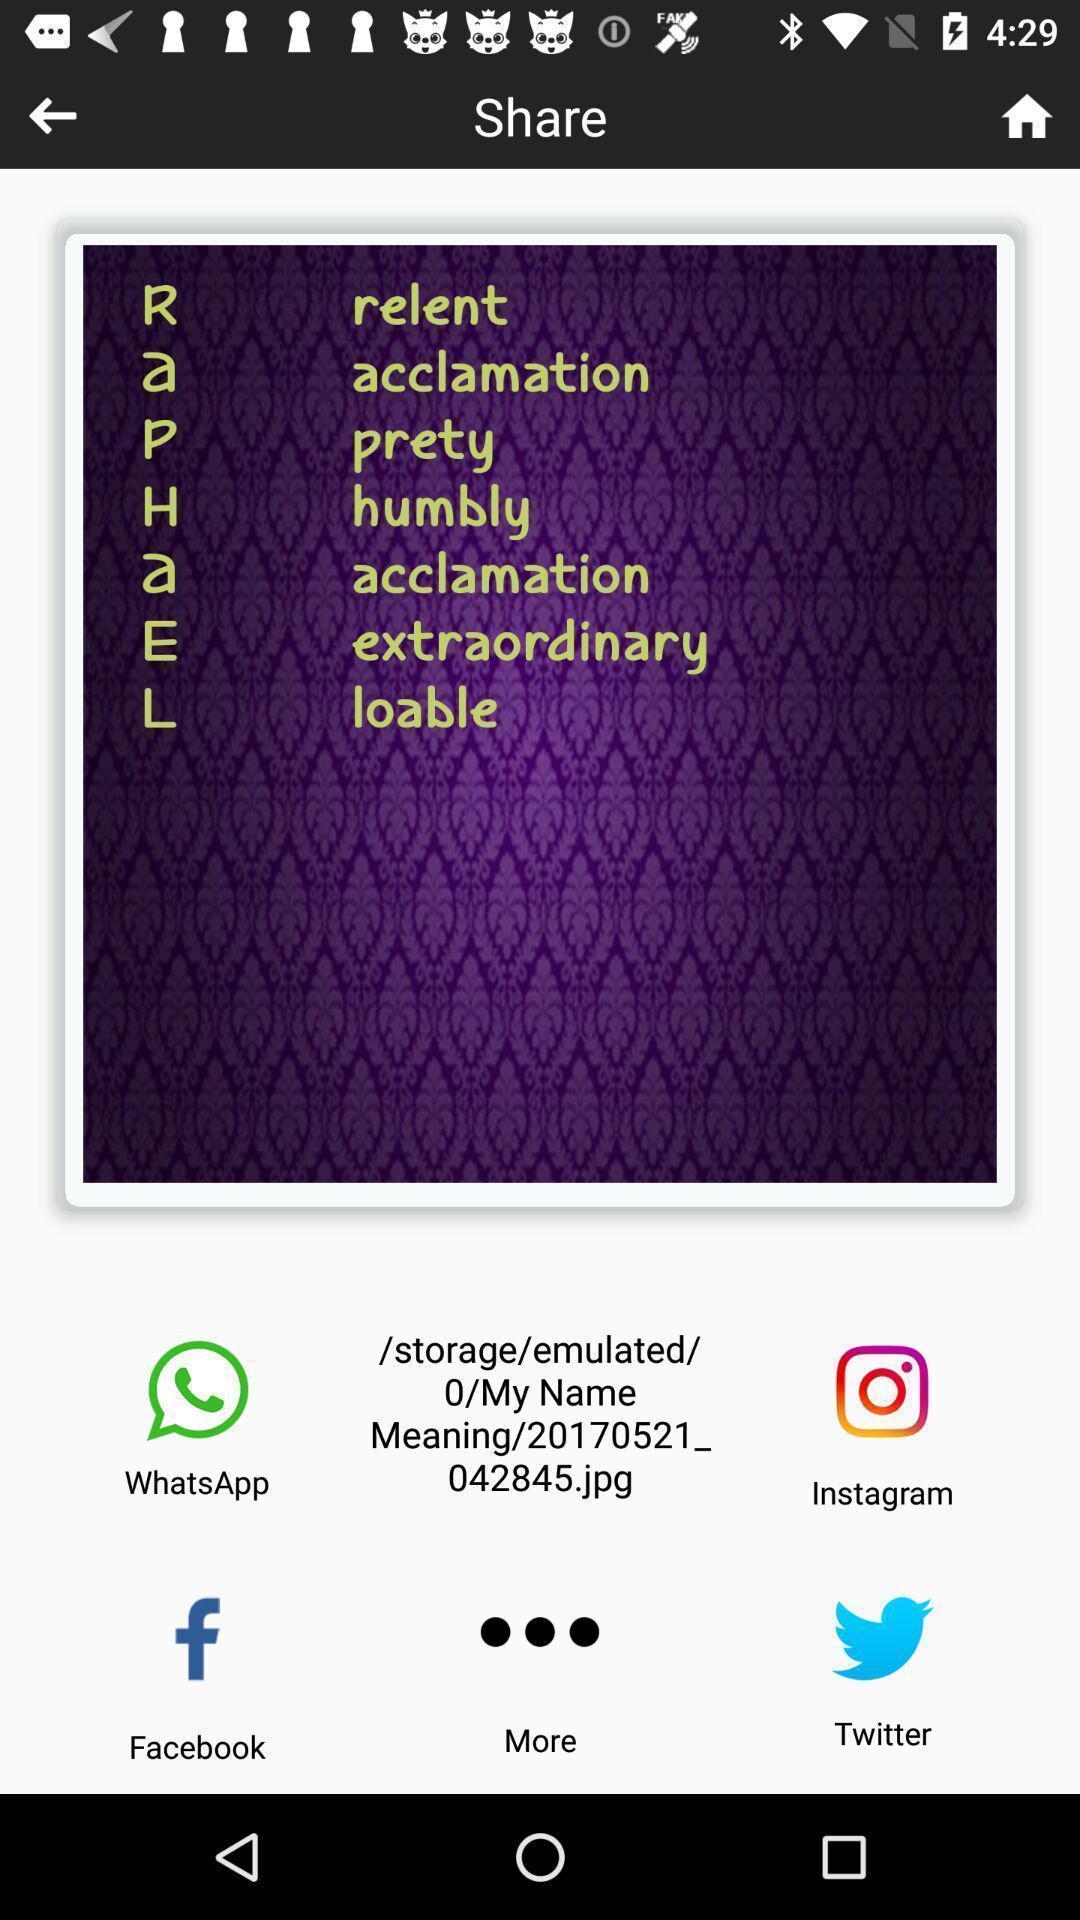Describe the content in this image. Sharing my name abbreviation via different social apps. 